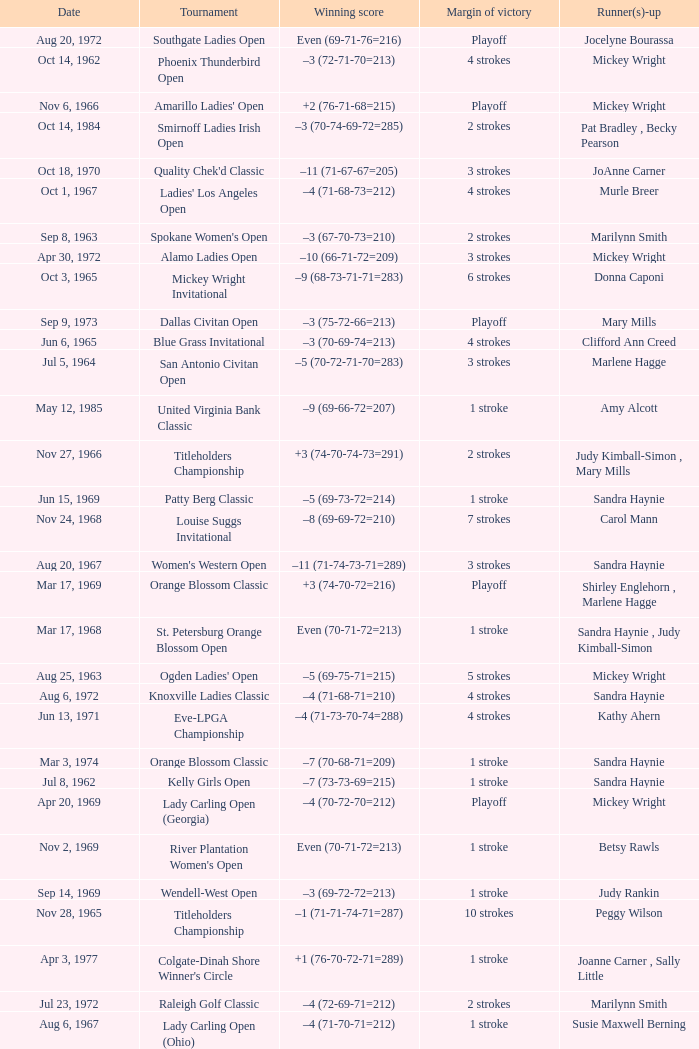What was the margin of victory on Apr 23, 1967? 5 strokes. Parse the table in full. {'header': ['Date', 'Tournament', 'Winning score', 'Margin of victory', 'Runner(s)-up'], 'rows': [['Aug 20, 1972', 'Southgate Ladies Open', 'Even (69-71-76=216)', 'Playoff', 'Jocelyne Bourassa'], ['Oct 14, 1962', 'Phoenix Thunderbird Open', '–3 (72-71-70=213)', '4 strokes', 'Mickey Wright'], ['Nov 6, 1966', "Amarillo Ladies' Open", '+2 (76-71-68=215)', 'Playoff', 'Mickey Wright'], ['Oct 14, 1984', 'Smirnoff Ladies Irish Open', '–3 (70-74-69-72=285)', '2 strokes', 'Pat Bradley , Becky Pearson'], ['Oct 18, 1970', "Quality Chek'd Classic", '–11 (71-67-67=205)', '3 strokes', 'JoAnne Carner'], ['Oct 1, 1967', "Ladies' Los Angeles Open", '–4 (71-68-73=212)', '4 strokes', 'Murle Breer'], ['Sep 8, 1963', "Spokane Women's Open", '–3 (67-70-73=210)', '2 strokes', 'Marilynn Smith'], ['Apr 30, 1972', 'Alamo Ladies Open', '–10 (66-71-72=209)', '3 strokes', 'Mickey Wright'], ['Oct 3, 1965', 'Mickey Wright Invitational', '–9 (68-73-71-71=283)', '6 strokes', 'Donna Caponi'], ['Sep 9, 1973', 'Dallas Civitan Open', '–3 (75-72-66=213)', 'Playoff', 'Mary Mills'], ['Jun 6, 1965', 'Blue Grass Invitational', '–3 (70-69-74=213)', '4 strokes', 'Clifford Ann Creed'], ['Jul 5, 1964', 'San Antonio Civitan Open', '–5 (70-72-71-70=283)', '3 strokes', 'Marlene Hagge'], ['May 12, 1985', 'United Virginia Bank Classic', '–9 (69-66-72=207)', '1 stroke', 'Amy Alcott'], ['Nov 27, 1966', 'Titleholders Championship', '+3 (74-70-74-73=291)', '2 strokes', 'Judy Kimball-Simon , Mary Mills'], ['Jun 15, 1969', 'Patty Berg Classic', '–5 (69-73-72=214)', '1 stroke', 'Sandra Haynie'], ['Nov 24, 1968', 'Louise Suggs Invitational', '–8 (69-69-72=210)', '7 strokes', 'Carol Mann'], ['Aug 20, 1967', "Women's Western Open", '–11 (71-74-73-71=289)', '3 strokes', 'Sandra Haynie'], ['Mar 17, 1969', 'Orange Blossom Classic', '+3 (74-70-72=216)', 'Playoff', 'Shirley Englehorn , Marlene Hagge'], ['Mar 17, 1968', 'St. Petersburg Orange Blossom Open', 'Even (70-71-72=213)', '1 stroke', 'Sandra Haynie , Judy Kimball-Simon'], ['Aug 25, 1963', "Ogden Ladies' Open", '–5 (69-75-71=215)', '5 strokes', 'Mickey Wright'], ['Aug 6, 1972', 'Knoxville Ladies Classic', '–4 (71-68-71=210)', '4 strokes', 'Sandra Haynie'], ['Jun 13, 1971', 'Eve-LPGA Championship', '–4 (71-73-70-74=288)', '4 strokes', 'Kathy Ahern'], ['Mar 3, 1974', 'Orange Blossom Classic', '–7 (70-68-71=209)', '1 stroke', 'Sandra Haynie'], ['Jul 8, 1962', 'Kelly Girls Open', '–7 (73-73-69=215)', '1 stroke', 'Sandra Haynie'], ['Apr 20, 1969', 'Lady Carling Open (Georgia)', '–4 (70-72-70=212)', 'Playoff', 'Mickey Wright'], ['Nov 2, 1969', "River Plantation Women's Open", 'Even (70-71-72=213)', '1 stroke', 'Betsy Rawls'], ['Sep 14, 1969', 'Wendell-West Open', '–3 (69-72-72=213)', '1 stroke', 'Judy Rankin'], ['Nov 28, 1965', 'Titleholders Championship', '–1 (71-71-74-71=287)', '10 strokes', 'Peggy Wilson'], ['Apr 3, 1977', "Colgate-Dinah Shore Winner's Circle", '+1 (76-70-72-71=289)', '1 stroke', 'Joanne Carner , Sally Little'], ['Jul 23, 1972', 'Raleigh Golf Classic', '–4 (72-69-71=212)', '2 strokes', 'Marilynn Smith'], ['Aug 6, 1967', 'Lady Carling Open (Ohio)', '–4 (71-70-71=212)', '1 stroke', 'Susie Maxwell Berning'], ['Sep 16, 1973', 'Southgate Ladies Open', '–2 (72-70=142)', '1 stroke', 'Gerda Boykin'], ['Jun 1, 1975', 'LPGA Championship', '–4 (70-70-75-73=288)', '1 stroke', 'Sandra Haynie'], ['Sep 23, 1973', 'Portland Ladies Open', '–2 (71-73=144)', '2 strokes', 'Sandra Palmer'], ['Oct 21, 1973', 'Waco Tribune Herald Ladies Classic', '–7 (68-72-69=209)', '4 strokes', 'Kathy Cornelius , Pam Higgins , Marilynn Smith'], ['May 26, 1968', 'Dallas Civitan Open', '–4 (70-70-69=209)', '1 stroke', 'Carol Mann'], ['Nov 10, 1963', 'San Antonio Civitan Open', '+7 (73-73-78-75=299)', 'Playoff', 'Mickey Wright'], ['Apr 23, 1967', 'Raleigh Ladies Invitational', '–1 (72-72-71=215)', '5 strokes', 'Susie Maxwell Berning'], ['Jun 30, 1963', 'Carvel Ladies Open', '–2 (72-74-71=217)', '1 stroke', 'Marilynn Smith'], ['Mar 23, 1969', 'Port Charlotte Invitational', '–1 (72-72-74=218)', '1 stroke', 'Sandra Haynie , Sandra Post'], ['Feb 11, 1973', 'Naples Lely Classic', '+3 (68-76-75=219)', '2 strokes', 'JoAnne Carner'], ['Aug 7, 1966', 'Lady Carling Open (Massachusetts)', '–5 (74-73-70=217)', '1 stroke', 'Carol Mann'], ['Nov 4, 1973', 'Lady Errol Classic', '–3 (68-75-70=213)', '2 strokes', 'Gloria Ehret , Shelley Hamlin'], ['Jul 18, 1965', 'Yankee Open', '–3 (73-68-72=213)', '2 strokes', 'Carol Mann'], ['Sep 16, 1984', 'Safeco Classic', '–9 (69-75-65-70=279)', '2 strokes', 'Laura Baugh , Marta Figueras-Dotti'], ['Oct 1, 1972', 'Portland Ladies Open', '–7 (75-69-68=212)', '4 strokes', 'Sandra Haynie'], ['Aug 4, 1963', 'Milwaukee Jaycee Open', '–2 (70-73-73-70=286)', '7 strokes', 'Jackie Pung , Louise Suggs'], ['Jul 30, 1966', 'Supertest Ladies Open', '–3 (71-70-72=213)', '3 strokes', 'Mickey Wright'], ['Oct 29, 1967', "Alamo Ladies' Open", '–3 (71-71-71=213)', '3 strokes', 'Sandra Haynie'], ['May 23, 1971', 'Suzuki Golf Internationale', '+1 (72-72-73=217)', '2 strokes', 'Sandra Haynie , Sandra Palmer'], ['Sep 14, 1975', 'Southgate Open', 'Even (72-72-69=213)', '4 strokes', 'Gerda Boykin'], ['Aug 13, 1966', 'Lady Carling Open (Maryland)', '–2 (70-71-73=214)', '3 strokes', 'Peggy Wilson'], ['Mar 11, 1973', 'S&H Green Stamp Classic', '–2 (73-71-70=214)', '2 strokes', 'Mary Mills'], ['Aug 22, 1976', 'Patty Berg Classic', '–7 (66-73-73=212)', '2 strokes', 'Sandra Post'], ['Oct 22, 1968', 'River Plantation Invitational', '–8 (67-70-68=205)', '8 strokes', 'Kathy Cornelius'], ['May 16, 1982', 'Lady Michelob', '–9 (69-68-70=207)', '4 strokes', 'Sharon Barrett Barbara Moxness'], ['Mar 22, 1970', 'Orange Blossom Classic', '+3 (73-72-71=216)', '1 stroke', 'Carol Mann'], ['Jun 6, 1971', 'Lady Carling Open', '–9 (71-68-71=210)', '6 strokes', 'Jane Blalock'], ['May 8, 1966', 'Tall City Open', '–5 (67-70-71=208)', '1 stroke', 'Mickey Wright'], ['Jun 7, 1967', "St. Louis Women's Invitational", '+2 (68-70-71=209)', '2 strokes', 'Carol Mann'], ['Sep 22, 1968', 'Kings River Open', '–8 (68-71-69=208)', '10 strokes', 'Sandra Haynie'], ['Jun 19, 1966', 'Milwaukee Jaycee Open', '–7 (68-71-69-65=273)', '12 strokes', 'Sandra Haynie'], ['Jun 5, 1966', 'Clayton Federal Invitational', '+1 (68-72-68=208)', '4 strokes', 'Shirley Englehorn'], ['Mar 30, 1969', 'Port Malabar Invitational', '–3 (68-72-70=210)', '4 strokes', 'Mickey Wright'], ['Mar 20, 1983', "Women's Kemper Open", '–4 (72-77-70-69=288)', '1 stroke', 'Dale Eggeling'], ['Jun 30, 1968', 'Lady Carling Open (Maryland)', '–2 (71-70-73=214)', '1 stroke', 'Carol Mann'], ['Apr 24, 1977', 'American Defender Classic', '–10 (69-68-69=206)', '1 stroke', 'Pat Bradley'], ['Mar 26, 1967', 'Venice Ladies Open', '+4 (70-71-76=217)', '1 stroke', 'Clifford Ann Creed , Gloria Ehret'], ['Aug 4, 1968', 'Gino Paoli Open', '–1 (69-72-74=215)', 'Playoff', 'Marlene Hagge'], ['May 2, 1965', 'Shreveport Kiwanis Invitational', '–6 (70-70-70=210)', '6 strokes', 'Patty Berg'], ['Jul 22, 1984', 'Rochester International', '–7 (73-68-71-69=281)', 'Playoff', 'Rosie Jones'], ['Jul 28, 1963', 'Wolverine Open', '–9 (72-64-62=198)', '5 strokes', 'Betsy Rawls'], ['May 17, 1981', 'Coca-Cola Classic', '–8 (69-72-70=211)', 'Playoff', 'Alice Ritzman'], ['Feb 7, 1976', 'Bent Tree Classic', '–7 (69-69-71=209)', '1 stroke', 'Hollis Stacy'], ['Aug 1, 1965', 'Lady Carling Midwest Open', 'Even (72-77-70=219)', '1 stroke', 'Sandra Haynie'], ['Sep 10, 1978', 'National Jewish Hospital Open', '–5 (70-75-66-65=276)', '3 strokes', 'Pat Bradley , Gloria Ehret , JoAnn Washam'], ['Jul 25, 1965', 'Buckeye Savings Invitational', '–6 (70-67-70=207)', '1 stroke', 'Susan Maxwell-Berning'], ['Aug 18, 1968', 'Holiday Inn Classic', '–1 (74-70-62=206)', '3 strokes', 'Judy Kimball-Simon , Carol Mann'], ['Nov 3, 1968', 'Canyon Ladies Classic', '+2 (78-69-71=218)', '2 strokes', 'Donna Caponi , Shirley Englehorn , Mary Mills'], ['Oct 20, 1963', 'Hillside Open', 'Even (70-72-77=219)', '4 strokes', 'Mickey Wright'], ['Nov 17, 1963', 'Mary Mills Mississippi Gulf Coast Invitational', 'Even (72-77-70=219)', '4 strokes', 'Mickey Wright'], ['Apr 18, 1971', 'Raleigh Golf Classic', '–4 (71-72-69=212)', '5 strokes', 'Pam Barnett'], ['Apr 18, 1982', "CPC Women's International", '–7 (73-68-73-67=281)', '9 strokes', 'Patty Sheehan'], ['Jul 16, 1967', 'LPGA Championship', '–8 (69-74-72-69=284)', '1 stroke', 'Shirley Englehorn'], ['Nov 17, 1968', 'Pensacola Ladies Invitational', '–3 (71-71-74=216)', '3 strokes', 'Jo Ann Prentice ,'], ['Mar 21, 1965', 'St. Petersburg Open', '–7 (70-66-71-74=281)', '4 strokes', 'Sandra Haynie'], ['Oct 30, 1966', 'Las Cruces Ladies Open', '–2 (69-71-74=214)', '6 strokes', 'Marilynn Smith'], ['May 22, 1977', 'LPGA Coca-Cola Classic', '–11 (67-68-67=202)', '3 strokes', 'Donna Caponi']]} 